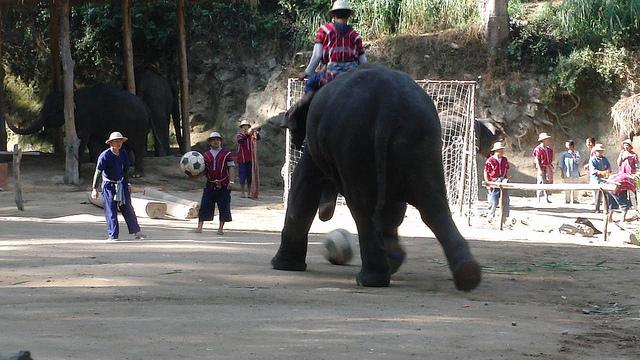What is this this elephant doing? walking 